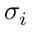Convert formula to latex. <formula><loc_0><loc_0><loc_500><loc_500>\sigma _ { i }</formula> 